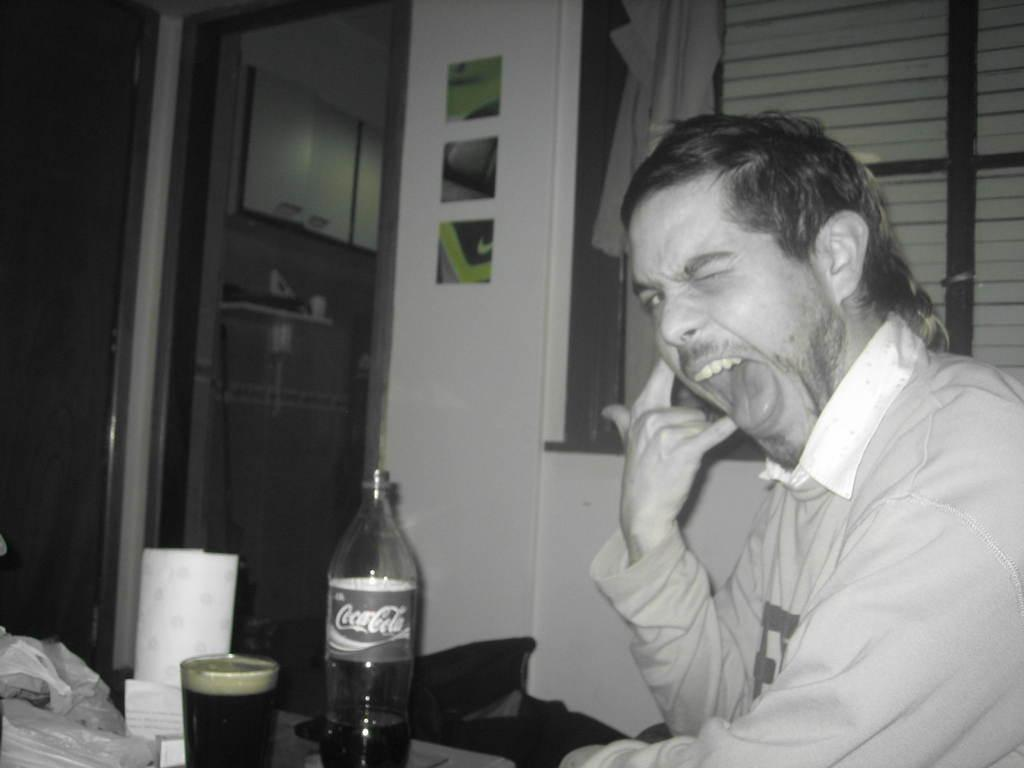What is the man in the image doing? There is a man sitting in the image. What objects are in front of the man? There is a coke bottle and a glass in front of the man. What can be seen behind the man? There is a window visible behind the man. Where is the vase with flowers located in the image? There is no vase with flowers present in the image. What type of plantation can be seen through the window in the image? There is no plantation visible through the window in the image. 